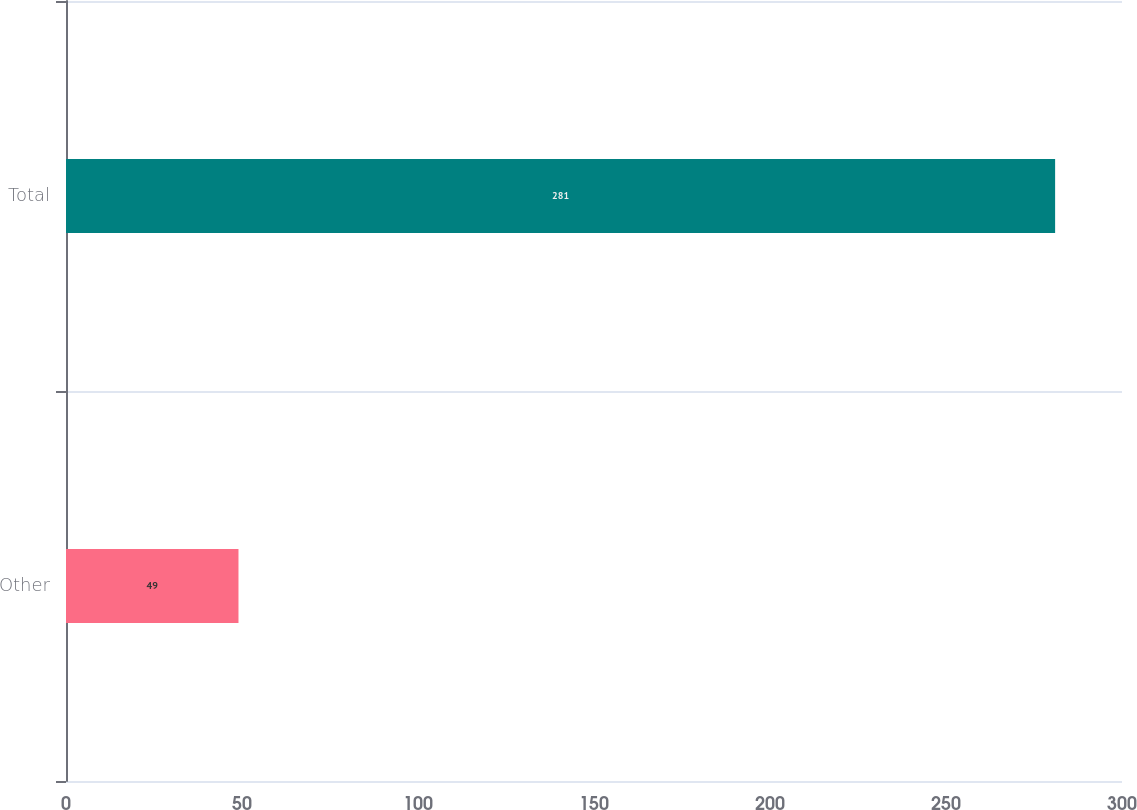<chart> <loc_0><loc_0><loc_500><loc_500><bar_chart><fcel>Other<fcel>Total<nl><fcel>49<fcel>281<nl></chart> 